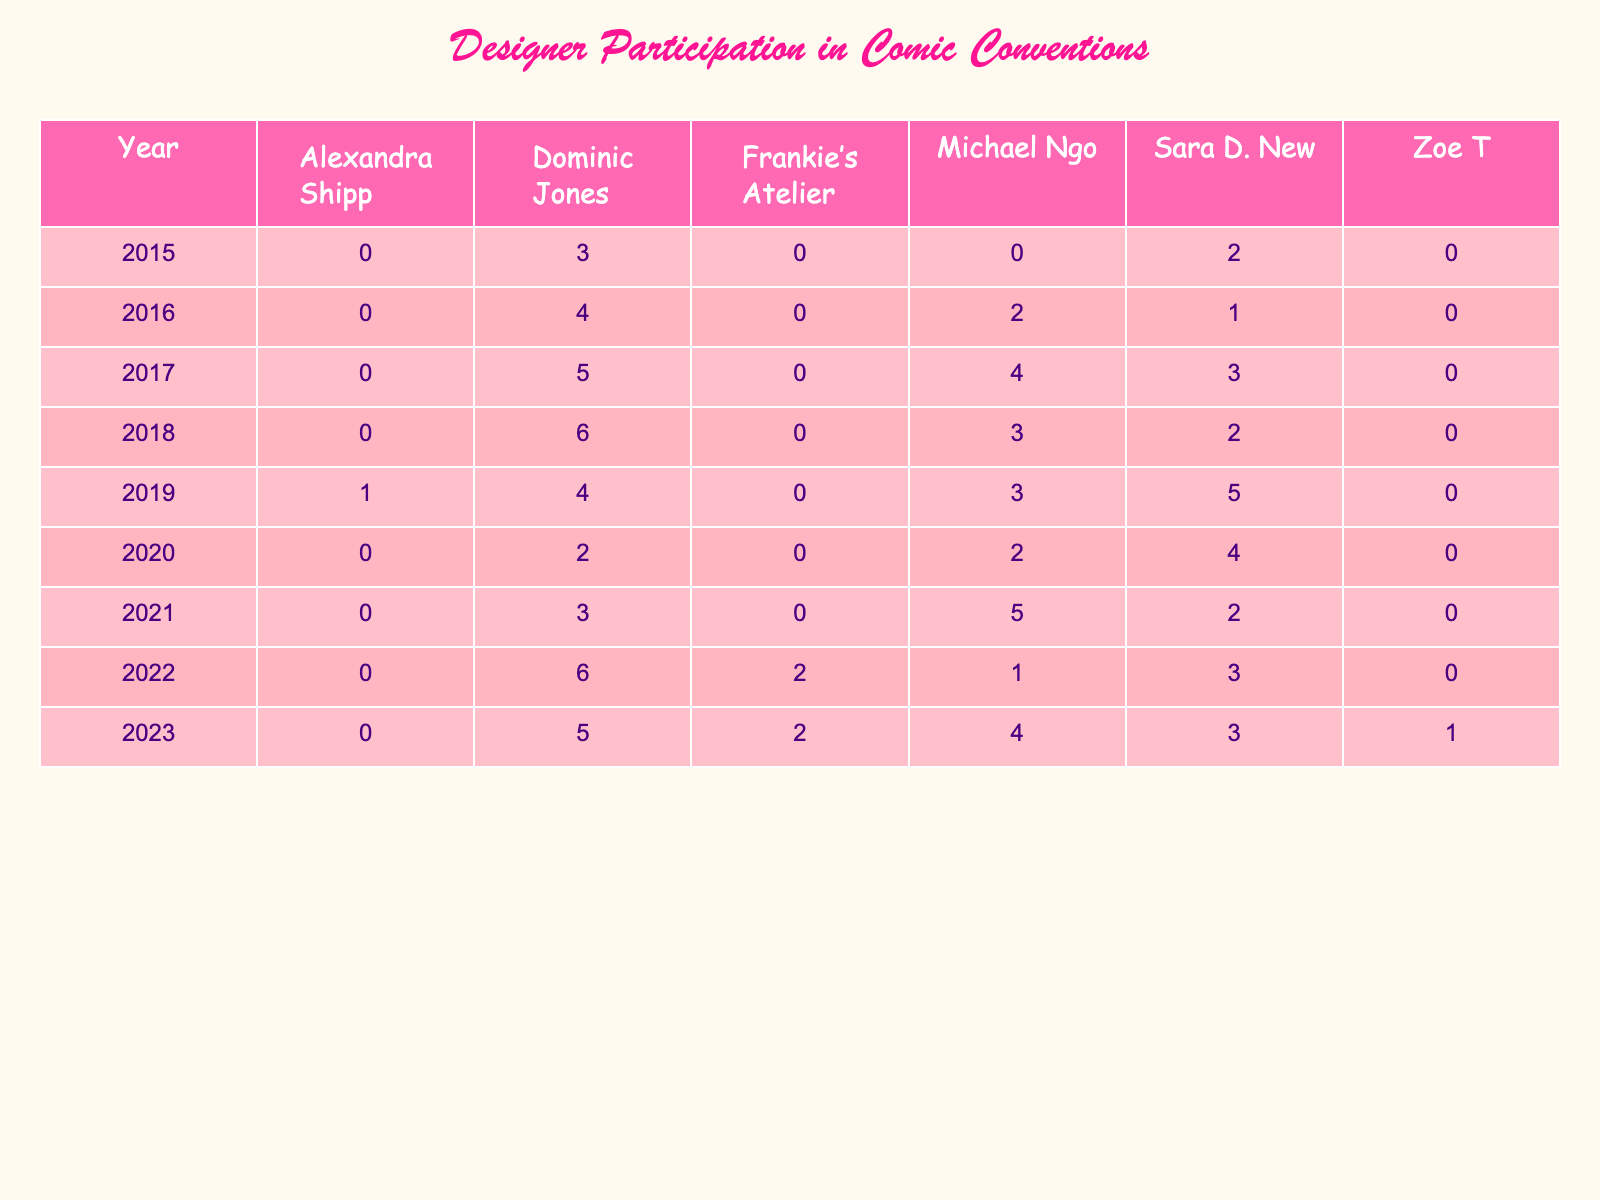What year did Dominic Jones participate the most in comic conventions? Looking at the table, the year with the highest frequency of participation for Dominic Jones is 2018 with 6 participations.
Answer: 2018 What was the total frequency of Sara D. New's participation over all the years? To find the total frequency for Sara D. New, we sum her participations: 2 (2015) + 1 (2016) + 3 (2017) + 2 (2018) + 5 (2019) + 4 (2020) + 2 (2021) + 3 (2022) + 3 (2023) = 22.
Answer: 22 Did Michael Ngo participate in 2022? In the table, we can see that Michael Ngo has a frequency of 1 participation in 2022. Therefore, he did participate.
Answer: Yes Which designer had the highest total participation across all years? To determine this, we calculate the total participation for each designer: Dominic Jones: 3 + 4 + 5 + 6 + 4 + 2 + 3 + 6 + 5 = 38; Sara D. New: 2 + 1 + 3 + 2 + 5 + 4 + 2 + 3 + 3 = 22; Michael Ngo: 2 + 2 + 4 + 3 + 3 + 2 + 5 + 1 + 4 = 22; Frankie’s Atelier: 2 + 2 = 4; Alexandra Shipp: 1. The highest is Dominic Jones with 38 participations.
Answer: Dominic Jones What was the average participation frequency of all designers in 2019? In 2019, we have the following participations: Dominic Jones (4), Sara D. New (5), Michael Ngo (3), and Alexandra Shipp (1). Adding these gives 4 + 5 + 3 + 1 = 13. There are 4 designers, so the average is 13 / 4 = 3.25.
Answer: 3.25 How many times did Frankie’s Atelier participate in comic conventions? From the data, Frankie’s Atelier participated 2 times in 2022 and 2 times in 2023. This totals to 4 participations.
Answer: 4 Which designer had the least participation in the year 2020? In 2020, the designers and their participations are: Dominic Jones (2), Sara D. New (4), and Michael Ngo (2). The least participation is 2, which was by both Dominic Jones and Michael Ngo.
Answer: Dominic Jones and Michael Ngo Was there a year when no designers participated? A closer look at the table shows that there are entries for every year from 2015 to 2023, meaning that there was participation in every year.
Answer: No 